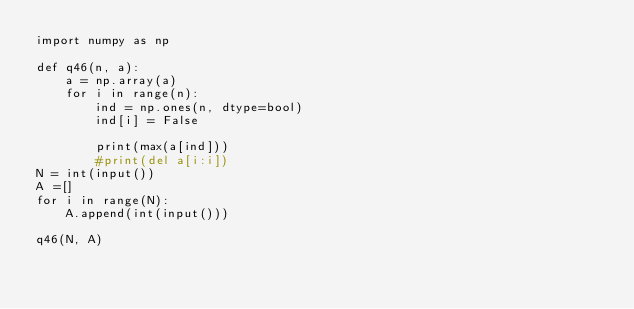<code> <loc_0><loc_0><loc_500><loc_500><_Python_>import numpy as np

def q46(n, a):
    a = np.array(a)
    for i in range(n):
        ind = np.ones(n, dtype=bool)
        ind[i] = False

        print(max(a[ind]))
        #print(del a[i:i])
N = int(input())
A =[]
for i in range(N):
    A.append(int(input()))

q46(N, A)</code> 